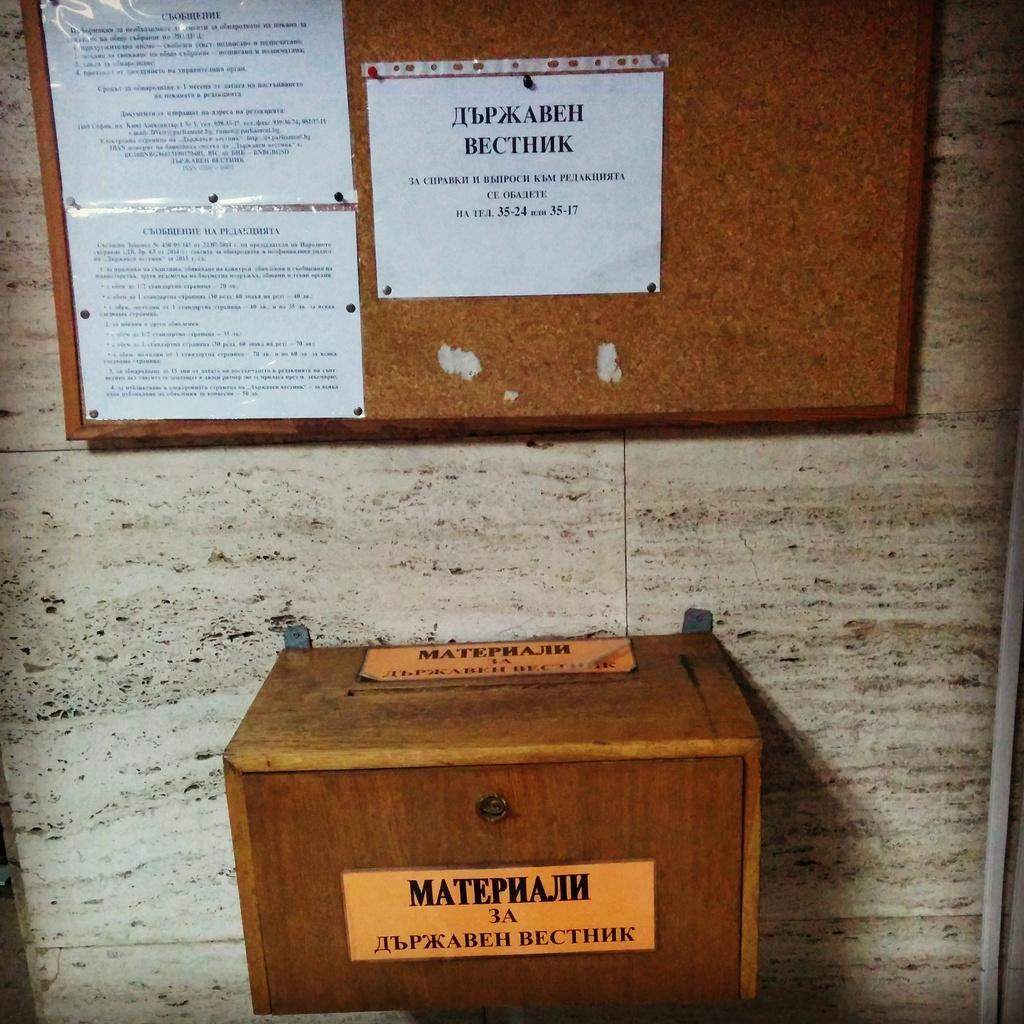<image>
Summarize the visual content of the image. The mailbox has the name Matephajih on it 